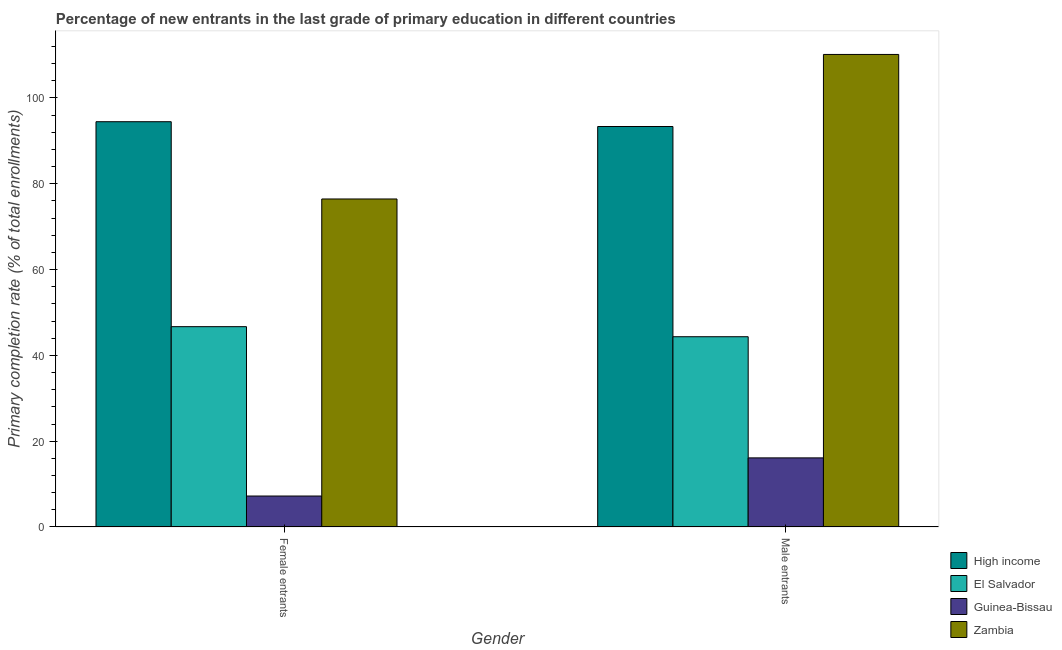How many different coloured bars are there?
Provide a short and direct response. 4. How many groups of bars are there?
Your answer should be very brief. 2. Are the number of bars on each tick of the X-axis equal?
Provide a short and direct response. Yes. How many bars are there on the 1st tick from the left?
Provide a short and direct response. 4. What is the label of the 1st group of bars from the left?
Ensure brevity in your answer.  Female entrants. What is the primary completion rate of male entrants in El Salvador?
Make the answer very short. 44.34. Across all countries, what is the maximum primary completion rate of male entrants?
Provide a succinct answer. 110.12. Across all countries, what is the minimum primary completion rate of male entrants?
Give a very brief answer. 16.11. In which country was the primary completion rate of male entrants maximum?
Provide a succinct answer. Zambia. In which country was the primary completion rate of female entrants minimum?
Offer a terse response. Guinea-Bissau. What is the total primary completion rate of male entrants in the graph?
Provide a short and direct response. 263.9. What is the difference between the primary completion rate of male entrants in Guinea-Bissau and that in El Salvador?
Your answer should be compact. -28.23. What is the difference between the primary completion rate of female entrants in Guinea-Bissau and the primary completion rate of male entrants in El Salvador?
Keep it short and to the point. -37.12. What is the average primary completion rate of male entrants per country?
Offer a terse response. 65.98. What is the difference between the primary completion rate of male entrants and primary completion rate of female entrants in Zambia?
Offer a very short reply. 33.68. In how many countries, is the primary completion rate of female entrants greater than 84 %?
Offer a terse response. 1. What is the ratio of the primary completion rate of male entrants in Zambia to that in El Salvador?
Provide a short and direct response. 2.48. In how many countries, is the primary completion rate of male entrants greater than the average primary completion rate of male entrants taken over all countries?
Your answer should be compact. 2. What does the 2nd bar from the left in Male entrants represents?
Provide a short and direct response. El Salvador. What does the 3rd bar from the right in Female entrants represents?
Offer a very short reply. El Salvador. How many bars are there?
Ensure brevity in your answer.  8. How many countries are there in the graph?
Give a very brief answer. 4. What is the difference between two consecutive major ticks on the Y-axis?
Offer a terse response. 20. Are the values on the major ticks of Y-axis written in scientific E-notation?
Ensure brevity in your answer.  No. Where does the legend appear in the graph?
Offer a very short reply. Bottom right. How many legend labels are there?
Give a very brief answer. 4. How are the legend labels stacked?
Offer a terse response. Vertical. What is the title of the graph?
Keep it short and to the point. Percentage of new entrants in the last grade of primary education in different countries. Does "Peru" appear as one of the legend labels in the graph?
Your answer should be compact. No. What is the label or title of the X-axis?
Provide a succinct answer. Gender. What is the label or title of the Y-axis?
Give a very brief answer. Primary completion rate (% of total enrollments). What is the Primary completion rate (% of total enrollments) in High income in Female entrants?
Ensure brevity in your answer.  94.45. What is the Primary completion rate (% of total enrollments) in El Salvador in Female entrants?
Your response must be concise. 46.68. What is the Primary completion rate (% of total enrollments) in Guinea-Bissau in Female entrants?
Make the answer very short. 7.22. What is the Primary completion rate (% of total enrollments) in Zambia in Female entrants?
Give a very brief answer. 76.45. What is the Primary completion rate (% of total enrollments) of High income in Male entrants?
Your response must be concise. 93.33. What is the Primary completion rate (% of total enrollments) in El Salvador in Male entrants?
Your answer should be compact. 44.34. What is the Primary completion rate (% of total enrollments) in Guinea-Bissau in Male entrants?
Your response must be concise. 16.11. What is the Primary completion rate (% of total enrollments) in Zambia in Male entrants?
Your response must be concise. 110.12. Across all Gender, what is the maximum Primary completion rate (% of total enrollments) in High income?
Provide a short and direct response. 94.45. Across all Gender, what is the maximum Primary completion rate (% of total enrollments) in El Salvador?
Give a very brief answer. 46.68. Across all Gender, what is the maximum Primary completion rate (% of total enrollments) in Guinea-Bissau?
Your answer should be compact. 16.11. Across all Gender, what is the maximum Primary completion rate (% of total enrollments) of Zambia?
Keep it short and to the point. 110.12. Across all Gender, what is the minimum Primary completion rate (% of total enrollments) of High income?
Offer a terse response. 93.33. Across all Gender, what is the minimum Primary completion rate (% of total enrollments) of El Salvador?
Provide a succinct answer. 44.34. Across all Gender, what is the minimum Primary completion rate (% of total enrollments) of Guinea-Bissau?
Your response must be concise. 7.22. Across all Gender, what is the minimum Primary completion rate (% of total enrollments) in Zambia?
Give a very brief answer. 76.45. What is the total Primary completion rate (% of total enrollments) in High income in the graph?
Provide a short and direct response. 187.78. What is the total Primary completion rate (% of total enrollments) in El Salvador in the graph?
Your answer should be very brief. 91.03. What is the total Primary completion rate (% of total enrollments) of Guinea-Bissau in the graph?
Keep it short and to the point. 23.33. What is the total Primary completion rate (% of total enrollments) in Zambia in the graph?
Ensure brevity in your answer.  186.57. What is the difference between the Primary completion rate (% of total enrollments) of High income in Female entrants and that in Male entrants?
Your response must be concise. 1.12. What is the difference between the Primary completion rate (% of total enrollments) in El Salvador in Female entrants and that in Male entrants?
Your answer should be compact. 2.34. What is the difference between the Primary completion rate (% of total enrollments) of Guinea-Bissau in Female entrants and that in Male entrants?
Offer a terse response. -8.89. What is the difference between the Primary completion rate (% of total enrollments) in Zambia in Female entrants and that in Male entrants?
Give a very brief answer. -33.68. What is the difference between the Primary completion rate (% of total enrollments) of High income in Female entrants and the Primary completion rate (% of total enrollments) of El Salvador in Male entrants?
Provide a short and direct response. 50.11. What is the difference between the Primary completion rate (% of total enrollments) in High income in Female entrants and the Primary completion rate (% of total enrollments) in Guinea-Bissau in Male entrants?
Your response must be concise. 78.34. What is the difference between the Primary completion rate (% of total enrollments) in High income in Female entrants and the Primary completion rate (% of total enrollments) in Zambia in Male entrants?
Offer a very short reply. -15.67. What is the difference between the Primary completion rate (% of total enrollments) of El Salvador in Female entrants and the Primary completion rate (% of total enrollments) of Guinea-Bissau in Male entrants?
Provide a succinct answer. 30.58. What is the difference between the Primary completion rate (% of total enrollments) in El Salvador in Female entrants and the Primary completion rate (% of total enrollments) in Zambia in Male entrants?
Your answer should be very brief. -63.44. What is the difference between the Primary completion rate (% of total enrollments) of Guinea-Bissau in Female entrants and the Primary completion rate (% of total enrollments) of Zambia in Male entrants?
Offer a terse response. -102.91. What is the average Primary completion rate (% of total enrollments) in High income per Gender?
Provide a short and direct response. 93.89. What is the average Primary completion rate (% of total enrollments) of El Salvador per Gender?
Provide a succinct answer. 45.51. What is the average Primary completion rate (% of total enrollments) of Guinea-Bissau per Gender?
Your answer should be compact. 11.66. What is the average Primary completion rate (% of total enrollments) of Zambia per Gender?
Ensure brevity in your answer.  93.28. What is the difference between the Primary completion rate (% of total enrollments) of High income and Primary completion rate (% of total enrollments) of El Salvador in Female entrants?
Your answer should be very brief. 47.77. What is the difference between the Primary completion rate (% of total enrollments) in High income and Primary completion rate (% of total enrollments) in Guinea-Bissau in Female entrants?
Give a very brief answer. 87.23. What is the difference between the Primary completion rate (% of total enrollments) in High income and Primary completion rate (% of total enrollments) in Zambia in Female entrants?
Ensure brevity in your answer.  18.01. What is the difference between the Primary completion rate (% of total enrollments) in El Salvador and Primary completion rate (% of total enrollments) in Guinea-Bissau in Female entrants?
Make the answer very short. 39.47. What is the difference between the Primary completion rate (% of total enrollments) of El Salvador and Primary completion rate (% of total enrollments) of Zambia in Female entrants?
Make the answer very short. -29.76. What is the difference between the Primary completion rate (% of total enrollments) in Guinea-Bissau and Primary completion rate (% of total enrollments) in Zambia in Female entrants?
Your answer should be very brief. -69.23. What is the difference between the Primary completion rate (% of total enrollments) in High income and Primary completion rate (% of total enrollments) in El Salvador in Male entrants?
Provide a succinct answer. 48.99. What is the difference between the Primary completion rate (% of total enrollments) of High income and Primary completion rate (% of total enrollments) of Guinea-Bissau in Male entrants?
Your answer should be compact. 77.22. What is the difference between the Primary completion rate (% of total enrollments) in High income and Primary completion rate (% of total enrollments) in Zambia in Male entrants?
Offer a terse response. -16.79. What is the difference between the Primary completion rate (% of total enrollments) of El Salvador and Primary completion rate (% of total enrollments) of Guinea-Bissau in Male entrants?
Give a very brief answer. 28.23. What is the difference between the Primary completion rate (% of total enrollments) of El Salvador and Primary completion rate (% of total enrollments) of Zambia in Male entrants?
Offer a terse response. -65.78. What is the difference between the Primary completion rate (% of total enrollments) of Guinea-Bissau and Primary completion rate (% of total enrollments) of Zambia in Male entrants?
Make the answer very short. -94.02. What is the ratio of the Primary completion rate (% of total enrollments) of High income in Female entrants to that in Male entrants?
Provide a succinct answer. 1.01. What is the ratio of the Primary completion rate (% of total enrollments) in El Salvador in Female entrants to that in Male entrants?
Give a very brief answer. 1.05. What is the ratio of the Primary completion rate (% of total enrollments) of Guinea-Bissau in Female entrants to that in Male entrants?
Offer a terse response. 0.45. What is the ratio of the Primary completion rate (% of total enrollments) in Zambia in Female entrants to that in Male entrants?
Provide a succinct answer. 0.69. What is the difference between the highest and the second highest Primary completion rate (% of total enrollments) of High income?
Provide a short and direct response. 1.12. What is the difference between the highest and the second highest Primary completion rate (% of total enrollments) in El Salvador?
Make the answer very short. 2.34. What is the difference between the highest and the second highest Primary completion rate (% of total enrollments) of Guinea-Bissau?
Your answer should be very brief. 8.89. What is the difference between the highest and the second highest Primary completion rate (% of total enrollments) of Zambia?
Give a very brief answer. 33.68. What is the difference between the highest and the lowest Primary completion rate (% of total enrollments) in High income?
Make the answer very short. 1.12. What is the difference between the highest and the lowest Primary completion rate (% of total enrollments) of El Salvador?
Provide a succinct answer. 2.34. What is the difference between the highest and the lowest Primary completion rate (% of total enrollments) in Guinea-Bissau?
Your answer should be compact. 8.89. What is the difference between the highest and the lowest Primary completion rate (% of total enrollments) of Zambia?
Offer a very short reply. 33.68. 